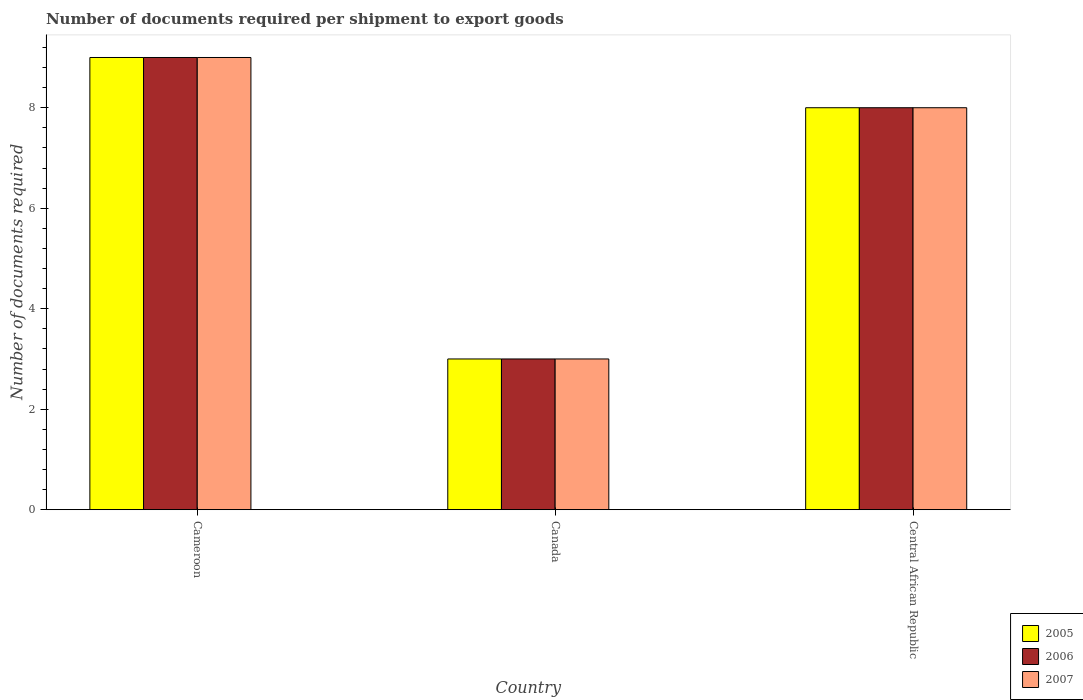How many different coloured bars are there?
Ensure brevity in your answer.  3. Are the number of bars per tick equal to the number of legend labels?
Keep it short and to the point. Yes. Are the number of bars on each tick of the X-axis equal?
Give a very brief answer. Yes. How many bars are there on the 3rd tick from the right?
Make the answer very short. 3. In how many cases, is the number of bars for a given country not equal to the number of legend labels?
Your answer should be compact. 0. What is the number of documents required per shipment to export goods in 2007 in Cameroon?
Make the answer very short. 9. Across all countries, what is the maximum number of documents required per shipment to export goods in 2005?
Provide a succinct answer. 9. Across all countries, what is the minimum number of documents required per shipment to export goods in 2006?
Your answer should be compact. 3. In which country was the number of documents required per shipment to export goods in 2006 maximum?
Make the answer very short. Cameroon. What is the average number of documents required per shipment to export goods in 2007 per country?
Provide a short and direct response. 6.67. In how many countries, is the number of documents required per shipment to export goods in 2006 greater than 1.6?
Your answer should be very brief. 3. Is the number of documents required per shipment to export goods in 2005 in Canada less than that in Central African Republic?
Your answer should be compact. Yes. Is the difference between the number of documents required per shipment to export goods in 2007 in Canada and Central African Republic greater than the difference between the number of documents required per shipment to export goods in 2005 in Canada and Central African Republic?
Provide a short and direct response. No. What is the difference between the highest and the lowest number of documents required per shipment to export goods in 2007?
Give a very brief answer. 6. What does the 3rd bar from the left in Canada represents?
Provide a short and direct response. 2007. What does the 3rd bar from the right in Cameroon represents?
Your response must be concise. 2005. How many bars are there?
Your answer should be compact. 9. What is the difference between two consecutive major ticks on the Y-axis?
Make the answer very short. 2. Does the graph contain any zero values?
Provide a short and direct response. No. Does the graph contain grids?
Keep it short and to the point. No. What is the title of the graph?
Provide a short and direct response. Number of documents required per shipment to export goods. What is the label or title of the X-axis?
Offer a terse response. Country. What is the label or title of the Y-axis?
Ensure brevity in your answer.  Number of documents required. What is the Number of documents required of 2007 in Cameroon?
Give a very brief answer. 9. What is the Number of documents required in 2005 in Canada?
Ensure brevity in your answer.  3. What is the Number of documents required of 2006 in Canada?
Your answer should be very brief. 3. What is the Number of documents required of 2006 in Central African Republic?
Provide a short and direct response. 8. What is the Number of documents required of 2007 in Central African Republic?
Provide a succinct answer. 8. Across all countries, what is the maximum Number of documents required of 2005?
Give a very brief answer. 9. Across all countries, what is the maximum Number of documents required in 2006?
Your answer should be compact. 9. Across all countries, what is the maximum Number of documents required of 2007?
Ensure brevity in your answer.  9. Across all countries, what is the minimum Number of documents required of 2006?
Provide a succinct answer. 3. What is the total Number of documents required in 2006 in the graph?
Ensure brevity in your answer.  20. What is the difference between the Number of documents required in 2005 in Cameroon and that in Canada?
Make the answer very short. 6. What is the difference between the Number of documents required of 2006 in Cameroon and that in Canada?
Your answer should be very brief. 6. What is the difference between the Number of documents required in 2005 in Cameroon and that in Central African Republic?
Keep it short and to the point. 1. What is the difference between the Number of documents required in 2006 in Canada and that in Central African Republic?
Give a very brief answer. -5. What is the difference between the Number of documents required in 2007 in Canada and that in Central African Republic?
Give a very brief answer. -5. What is the difference between the Number of documents required in 2005 in Cameroon and the Number of documents required in 2006 in Canada?
Your answer should be compact. 6. What is the difference between the Number of documents required of 2006 in Cameroon and the Number of documents required of 2007 in Canada?
Your answer should be compact. 6. What is the difference between the Number of documents required in 2005 in Cameroon and the Number of documents required in 2007 in Central African Republic?
Your answer should be very brief. 1. What is the average Number of documents required of 2006 per country?
Offer a terse response. 6.67. What is the difference between the Number of documents required of 2005 and Number of documents required of 2006 in Cameroon?
Provide a short and direct response. 0. What is the difference between the Number of documents required in 2006 and Number of documents required in 2007 in Cameroon?
Offer a terse response. 0. What is the difference between the Number of documents required of 2005 and Number of documents required of 2006 in Canada?
Provide a succinct answer. 0. What is the difference between the Number of documents required of 2005 and Number of documents required of 2007 in Canada?
Your response must be concise. 0. What is the difference between the Number of documents required of 2006 and Number of documents required of 2007 in Canada?
Make the answer very short. 0. What is the difference between the Number of documents required in 2005 and Number of documents required in 2007 in Central African Republic?
Keep it short and to the point. 0. What is the difference between the Number of documents required in 2006 and Number of documents required in 2007 in Central African Republic?
Provide a short and direct response. 0. What is the ratio of the Number of documents required of 2006 in Canada to that in Central African Republic?
Provide a short and direct response. 0.38. What is the difference between the highest and the second highest Number of documents required in 2005?
Give a very brief answer. 1. What is the difference between the highest and the second highest Number of documents required in 2006?
Offer a very short reply. 1. What is the difference between the highest and the lowest Number of documents required in 2007?
Your response must be concise. 6. 